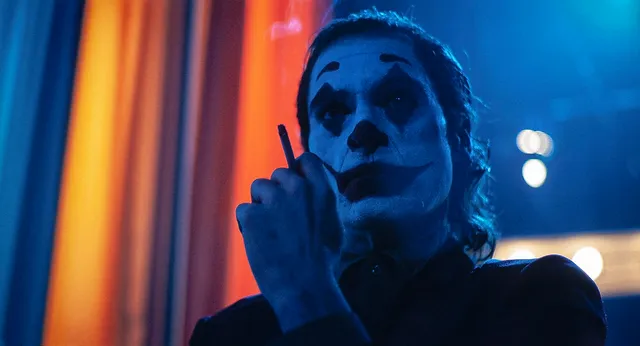What are the key elements in this picture? In this striking image, the acclaimed actor Joaquin Phoenix is depicted fully immersed in his iconic role as the Joker. Key elements of the picture include Phoenix's intense expression, characterized by the Joker's distinctive white makeup with black accents around the eyes and mouth. He is holding a cigarette to his lips, adding a layer of raw tension to the scene. The background consists of a curtain with alternating blue and orange hues, enhancing the contrast and accentuating the dramatic atmosphere. This image captures a haunting and captivating moment, testifying to Phoenix's remarkable transformative performance. 